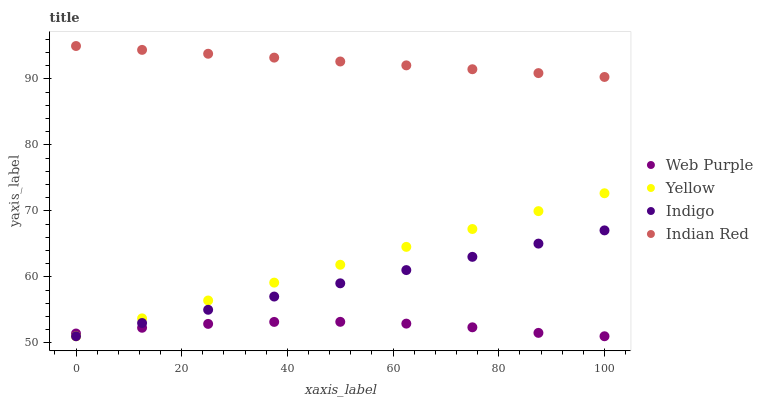Does Web Purple have the minimum area under the curve?
Answer yes or no. Yes. Does Indian Red have the maximum area under the curve?
Answer yes or no. Yes. Does Indigo have the minimum area under the curve?
Answer yes or no. No. Does Indigo have the maximum area under the curve?
Answer yes or no. No. Is Indigo the smoothest?
Answer yes or no. Yes. Is Web Purple the roughest?
Answer yes or no. Yes. Is Indian Red the smoothest?
Answer yes or no. No. Is Indian Red the roughest?
Answer yes or no. No. Does Web Purple have the lowest value?
Answer yes or no. Yes. Does Indian Red have the lowest value?
Answer yes or no. No. Does Indian Red have the highest value?
Answer yes or no. Yes. Does Indigo have the highest value?
Answer yes or no. No. Is Indigo less than Indian Red?
Answer yes or no. Yes. Is Indian Red greater than Indigo?
Answer yes or no. Yes. Does Yellow intersect Indigo?
Answer yes or no. Yes. Is Yellow less than Indigo?
Answer yes or no. No. Is Yellow greater than Indigo?
Answer yes or no. No. Does Indigo intersect Indian Red?
Answer yes or no. No. 